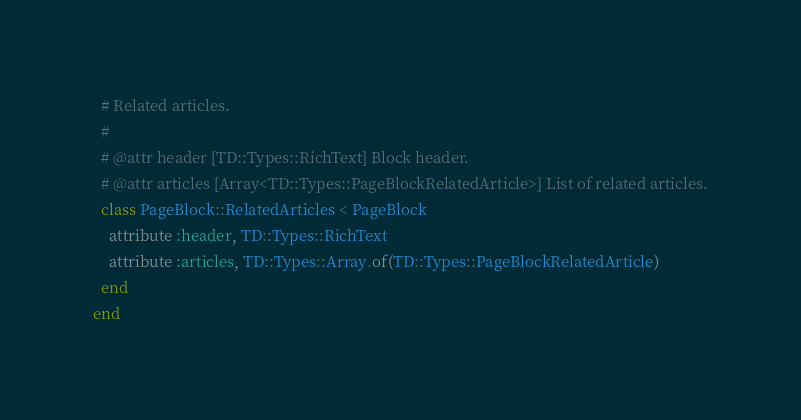Convert code to text. <code><loc_0><loc_0><loc_500><loc_500><_Ruby_>  # Related articles.
  #
  # @attr header [TD::Types::RichText] Block header.
  # @attr articles [Array<TD::Types::PageBlockRelatedArticle>] List of related articles.
  class PageBlock::RelatedArticles < PageBlock
    attribute :header, TD::Types::RichText
    attribute :articles, TD::Types::Array.of(TD::Types::PageBlockRelatedArticle)
  end
end
</code> 